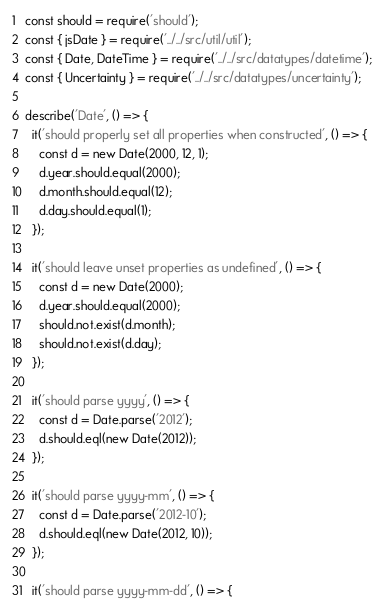Convert code to text. <code><loc_0><loc_0><loc_500><loc_500><_JavaScript_>const should = require('should');
const { jsDate } = require('../../src/util/util');
const { Date, DateTime } = require('../../src/datatypes/datetime');
const { Uncertainty } = require('../../src/datatypes/uncertainty');

describe('Date', () => {
  it('should properly set all properties when constructed', () => {
    const d = new Date(2000, 12, 1);
    d.year.should.equal(2000);
    d.month.should.equal(12);
    d.day.should.equal(1);
  });

  it('should leave unset properties as undefined', () => {
    const d = new Date(2000);
    d.year.should.equal(2000);
    should.not.exist(d.month);
    should.not.exist(d.day);
  });

  it('should parse yyyy', () => {
    const d = Date.parse('2012');
    d.should.eql(new Date(2012));
  });

  it('should parse yyyy-mm', () => {
    const d = Date.parse('2012-10');
    d.should.eql(new Date(2012, 10));
  });

  it('should parse yyyy-mm-dd', () => {</code> 